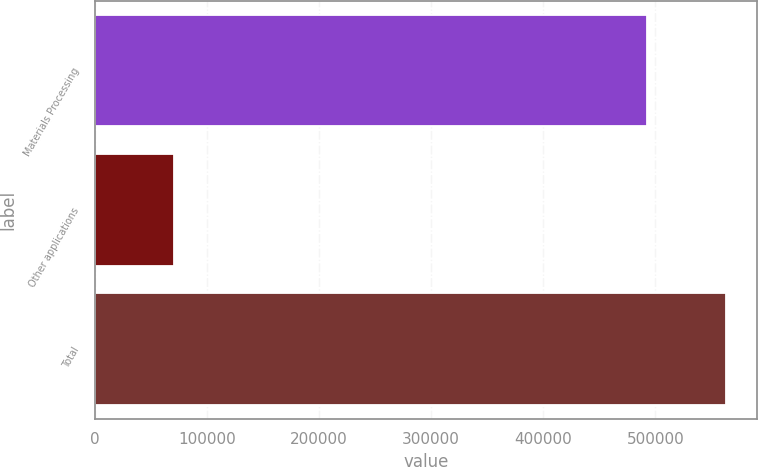<chart> <loc_0><loc_0><loc_500><loc_500><bar_chart><fcel>Materials Processing<fcel>Other applications<fcel>Total<nl><fcel>492013<fcel>70515<fcel>562528<nl></chart> 